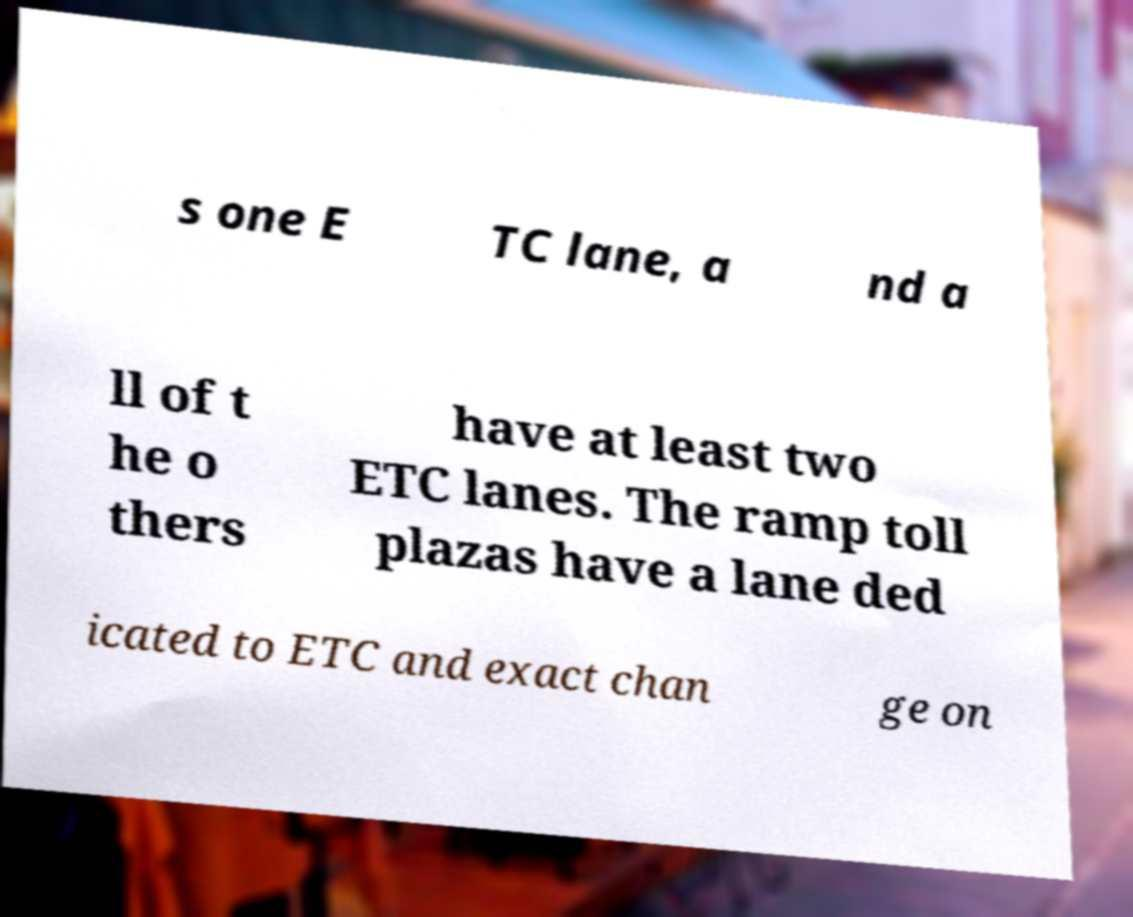There's text embedded in this image that I need extracted. Can you transcribe it verbatim? s one E TC lane, a nd a ll of t he o thers have at least two ETC lanes. The ramp toll plazas have a lane ded icated to ETC and exact chan ge on 